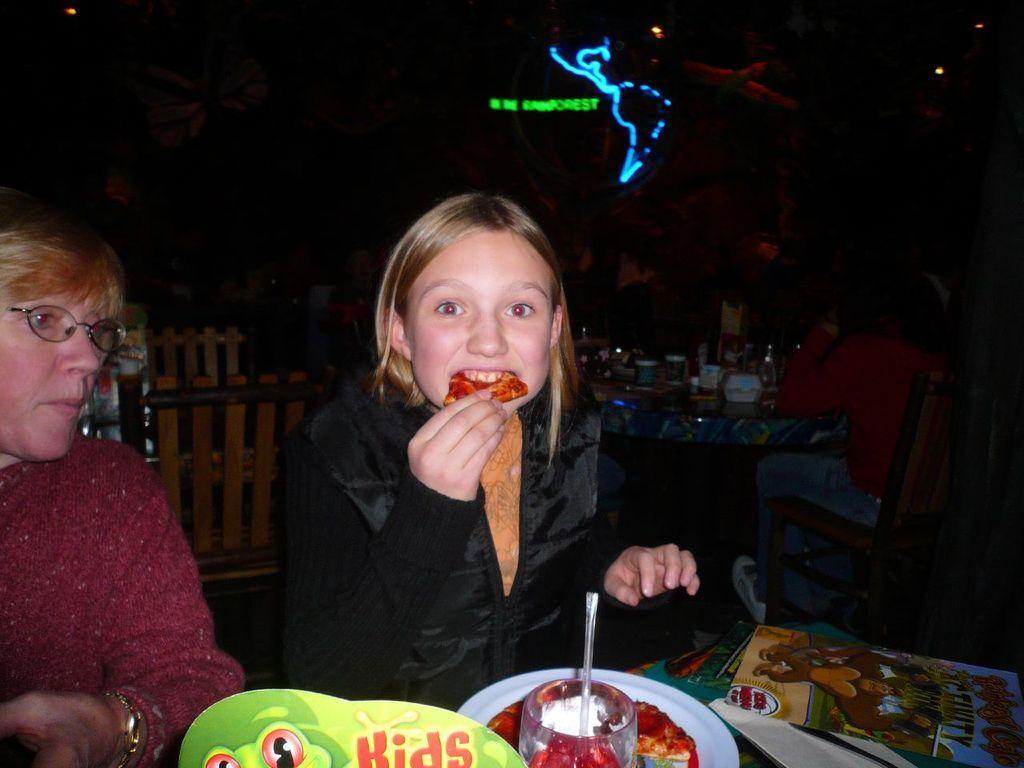Please provide a concise description of this image. In this image there are two women sitting, the woman is eating, there are chairs, there are persons sitting on the chair, there are tables, there are objects on the table towards the bottom of the image, there are lights, there is text, the background of the image is dark. 